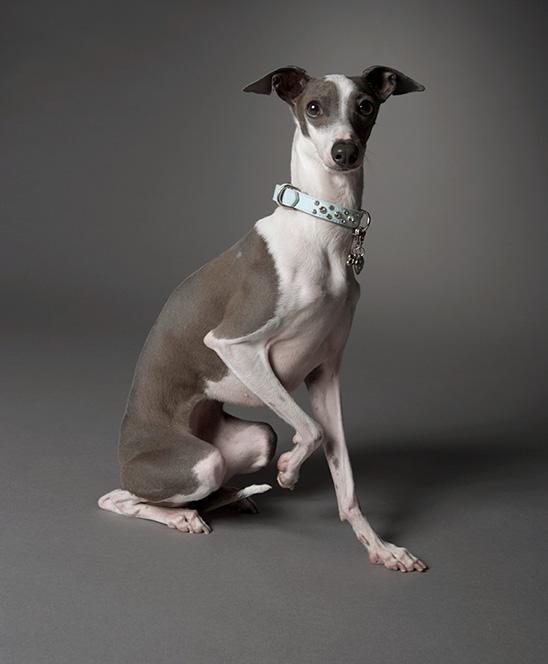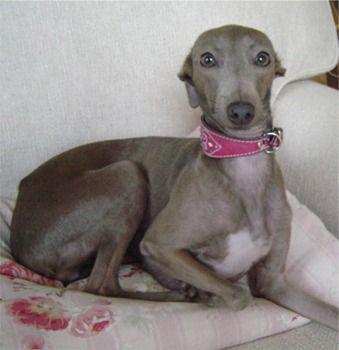The first image is the image on the left, the second image is the image on the right. Assess this claim about the two images: "Both of the images show dogs that look like puppies.". Correct or not? Answer yes or no. No. The first image is the image on the left, the second image is the image on the right. Assess this claim about the two images: "Each image contains an entire dog's body.". Correct or not? Answer yes or no. Yes. The first image is the image on the left, the second image is the image on the right. Examine the images to the left and right. Is the description "At least one dog is wearing a collar." accurate? Answer yes or no. Yes. The first image is the image on the left, the second image is the image on the right. Considering the images on both sides, is "An image shows a hound wearing a collar and sitting upright." valid? Answer yes or no. Yes. 